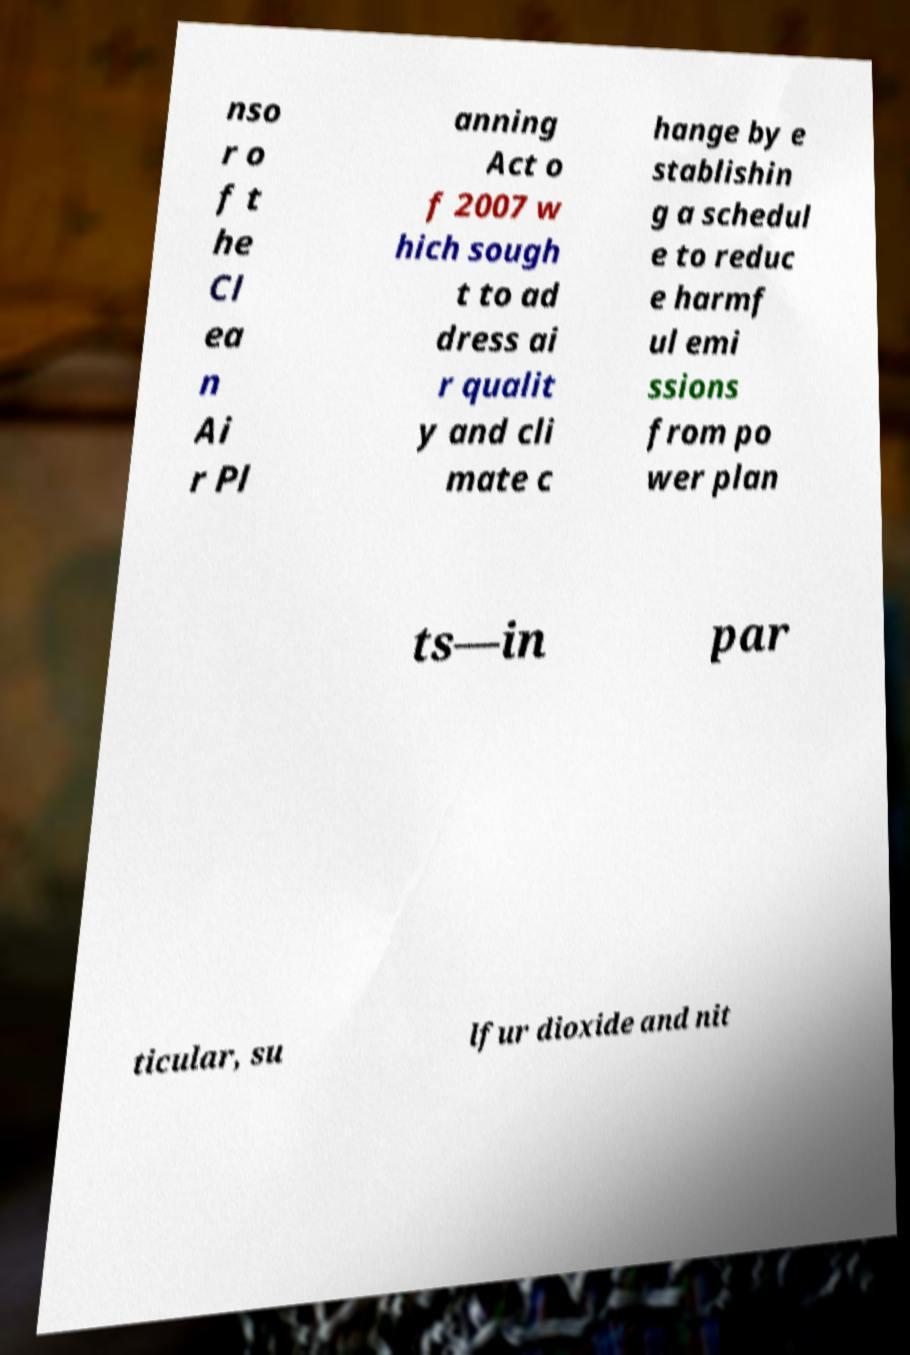For documentation purposes, I need the text within this image transcribed. Could you provide that? nso r o f t he Cl ea n Ai r Pl anning Act o f 2007 w hich sough t to ad dress ai r qualit y and cli mate c hange by e stablishin g a schedul e to reduc e harmf ul emi ssions from po wer plan ts—in par ticular, su lfur dioxide and nit 